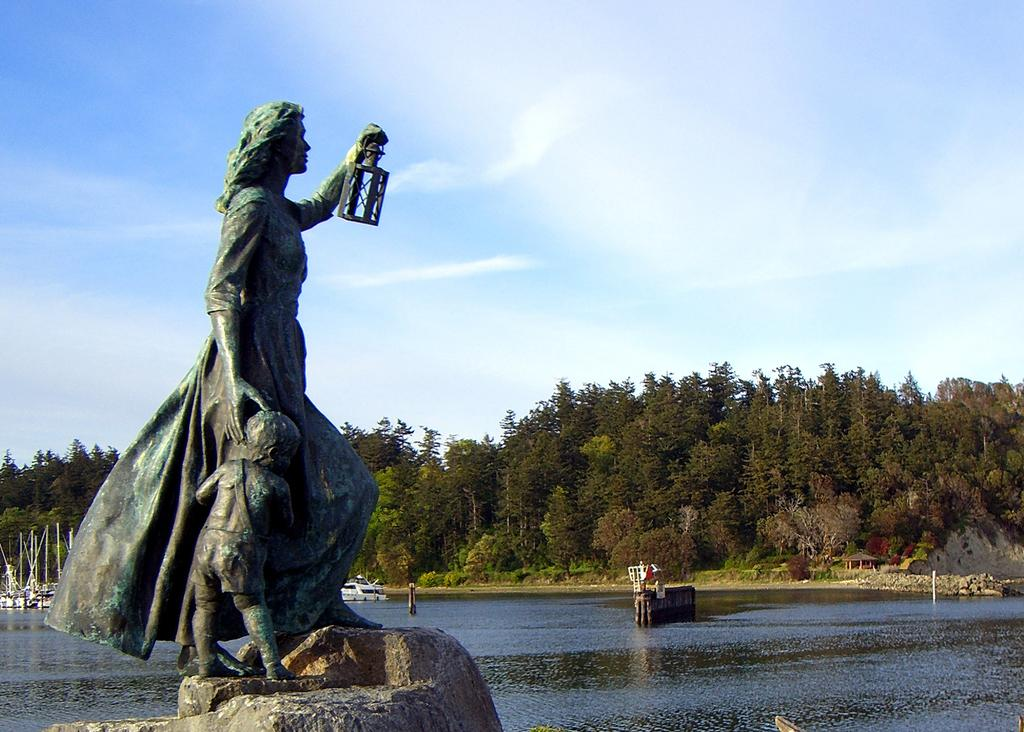What is the main subject in the image? There is a statue in the image. What can be seen in the background of the image? There are ships visible in the water, trees on the ground, and the sky in the background. What type of steam is coming out of the statue in the image? There is no steam coming out of the statue in the image. 